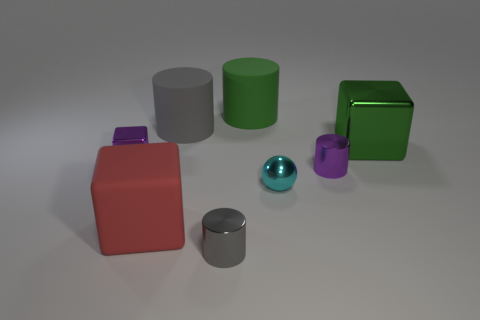Subtract all cyan cubes. How many gray cylinders are left? 2 Subtract all green cylinders. How many cylinders are left? 3 Subtract all tiny purple cylinders. How many cylinders are left? 3 Subtract all yellow cylinders. Subtract all blue balls. How many cylinders are left? 4 Add 2 green matte objects. How many objects exist? 10 Subtract all blocks. How many objects are left? 5 Add 8 gray objects. How many gray objects are left? 10 Add 7 large gray cylinders. How many large gray cylinders exist? 8 Subtract 0 red balls. How many objects are left? 8 Subtract all big green matte cylinders. Subtract all large gray cylinders. How many objects are left? 6 